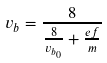Convert formula to latex. <formula><loc_0><loc_0><loc_500><loc_500>v _ { b } = \frac { 8 } { \frac { 8 } { v _ { b _ { 0 } } } + \frac { e f } { m } }</formula> 